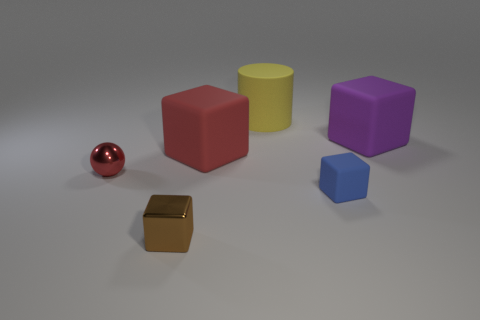Subtract all red blocks. How many blocks are left? 3 Add 2 large gray metal blocks. How many objects exist? 8 Subtract all purple cubes. How many cubes are left? 3 Subtract 2 cubes. How many cubes are left? 2 Subtract all metal blocks. Subtract all brown cubes. How many objects are left? 4 Add 2 blue blocks. How many blue blocks are left? 3 Add 5 tiny red metal things. How many tiny red metal things exist? 6 Subtract 0 green cubes. How many objects are left? 6 Subtract all blocks. How many objects are left? 2 Subtract all gray blocks. Subtract all red balls. How many blocks are left? 4 